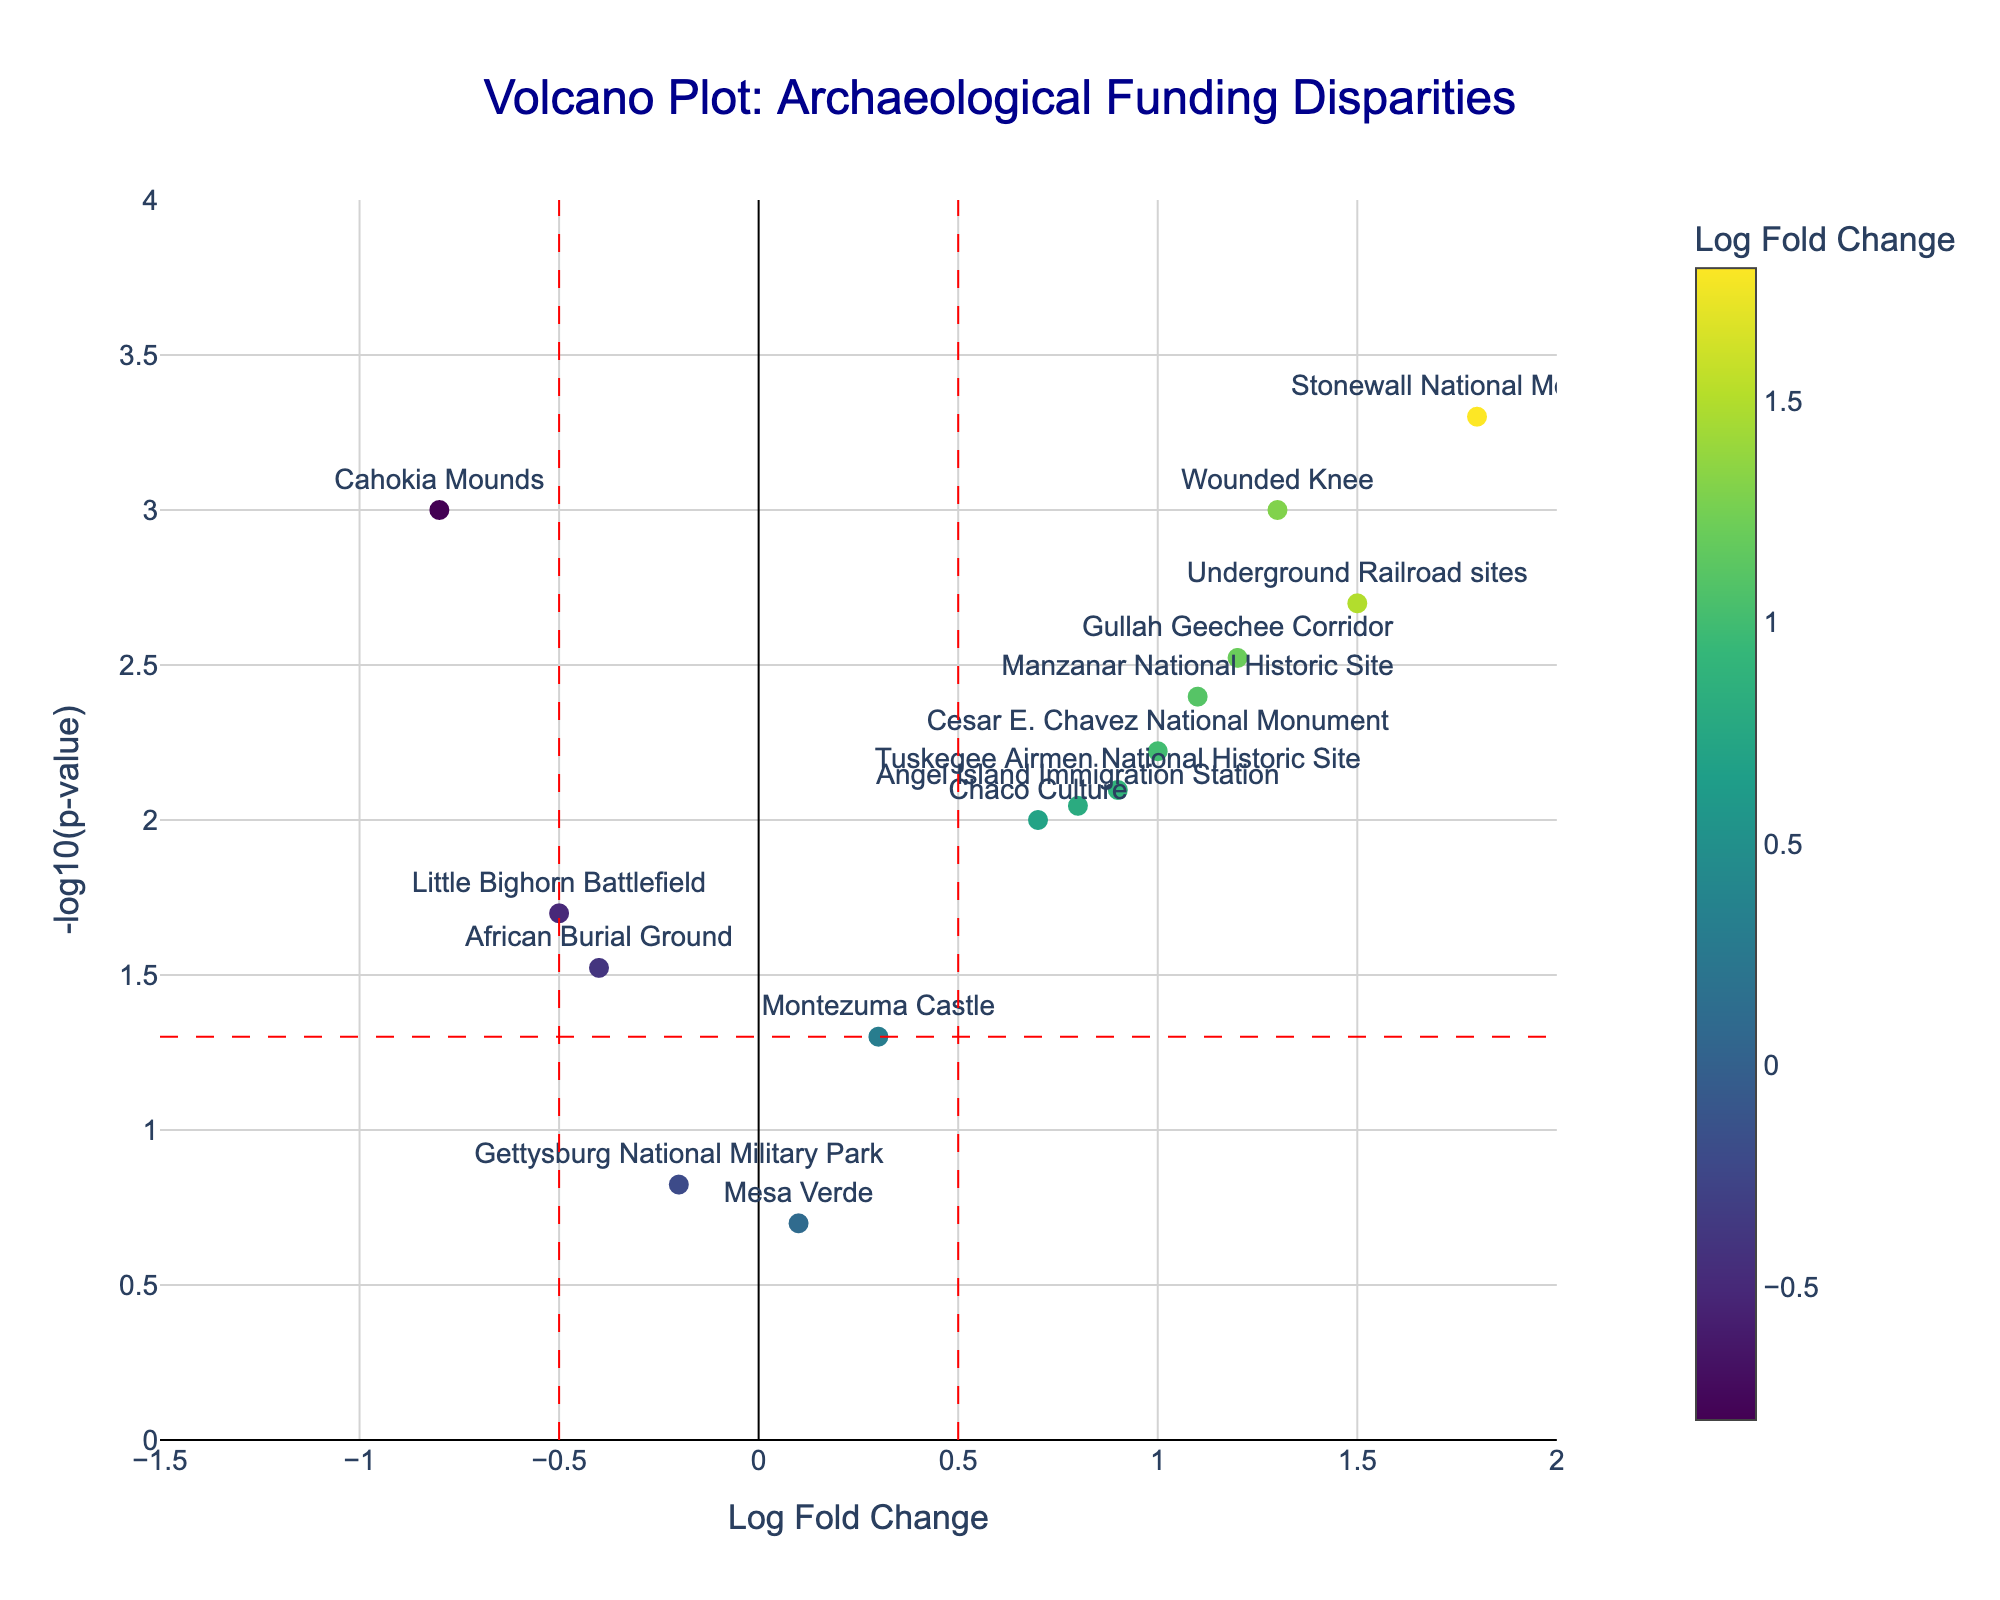What's the title of the figure? The title is usually displayed at the top of the plot. Here, the title is indicated as "Volcano Plot: Archaeological Funding Disparities".
Answer: Volcano Plot: Archaeological Funding Disparities What's the x-axis label in the figure? The x-axis label is noted in the plot configuration as "Log Fold Change". This indicates that the x-axis represents the log fold change values.
Answer: Log Fold Change Which site has the highest log fold change value? By looking at the plot, the site farthest to the right on the x-axis has the highest log fold change. Here, that site is "Stonewall National Monument" with a log fold change of 1.8.
Answer: Stonewall National Monument How many sites have a log fold change greater than 1? The log fold change values greater than 1 appear to the right of the 1 mark on the x-axis. By visual identification, four sites meet this criterion.
Answer: 4 Which site has the lowest p-value? The lowest p-value corresponds to the highest point on the y-axis (-log10(p-value)). Here, "Stonewall National Monument" is at the highest y position, indicating it has the lowest p-value of 0.0005.
Answer: Stonewall National Monument What can be inferred from sites that appear above the horizontal red dashed line? Sites above the red dashed line have p-values less than 0.05 since the line represents -log10(0.05). Looking at the plot, 9 sites appear above this line. These sites are considered statistically significant.
Answer: They are statistically significant Which mainstream historical site has a lower log fold change compared to minority-related sites such as "Underground Railroad sites"? "Gettysburg National Military Park" has a lower log fold change of -0.2 compared to minority-related sites such as "Underground Railroad sites" with a log fold change of 1.5.
Answer: Gettysburg National Military Park What is the relationship between the log fold change and statistical significance in this plot? In this Volcano Plot, points farther to the right (high log fold change) and higher on the y-axis (high -log10(p-value)) indicate significant increases in funding disparities towards these sites. Conversely, points to the left and lower on the y-axis show lesser importance and significance. For example, "Stonewall National Monument" with a high log fold change and low p-value shows a significant disparity in funding towards minority representation.
Answer: Significant disparities are indicated by high log fold change and low p-value Which site related to minority culture has a log fold change closest to zero? Sites related to minority cultures identified in the data that have log fold change values close to zero can be found visually near the center of the x-axis. Here, "Mesa Verde" is closest to zero with a log fold change of 0.1, but it is actually a mainstream site. Among minority-related sites, "Montezuma Castle" is closest with 0.3.
Answer: Montezuma Castle 